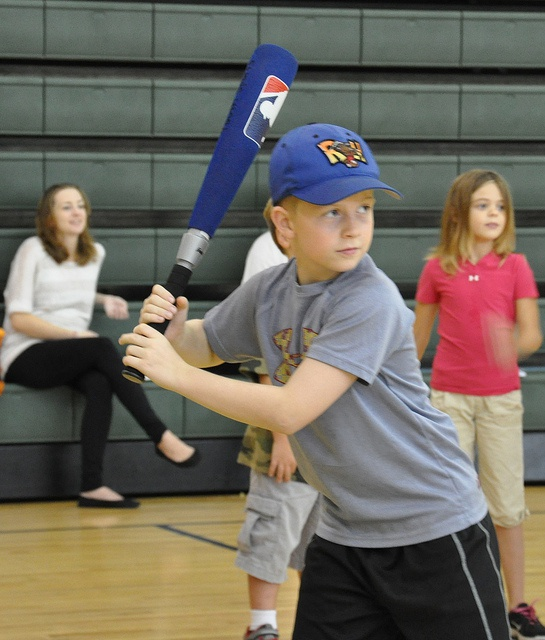Describe the objects in this image and their specific colors. I can see people in gray, black, darkgray, and tan tones, people in gray, salmon, tan, and brown tones, people in gray, black, lightgray, darkgray, and tan tones, baseball bat in gray, navy, darkblue, and black tones, and people in gray, darkgray, and tan tones in this image. 